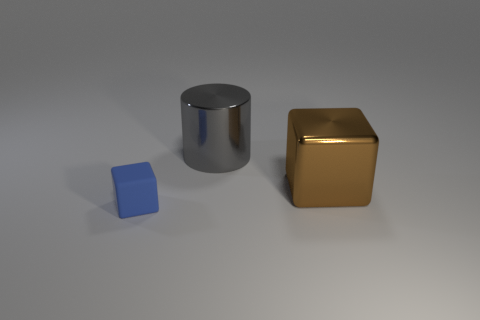What color is the cylinder?
Offer a very short reply. Gray. There is a cube that is to the left of the gray cylinder; is its color the same as the cylinder?
Make the answer very short. No. There is another rubber object that is the same shape as the large brown object; what color is it?
Give a very brief answer. Blue. How many big things are gray metallic objects or brown metal objects?
Offer a terse response. 2. What size is the block that is left of the gray metallic thing?
Your response must be concise. Small. Is there another matte cube of the same color as the matte block?
Offer a terse response. No. Is the color of the cylinder the same as the matte block?
Your response must be concise. No. What number of large gray metallic cylinders are in front of the cube behind the tiny blue rubber cube?
Offer a terse response. 0. What number of other blocks have the same material as the tiny cube?
Provide a short and direct response. 0. There is a small blue rubber block; are there any brown cubes left of it?
Your answer should be very brief. No. 